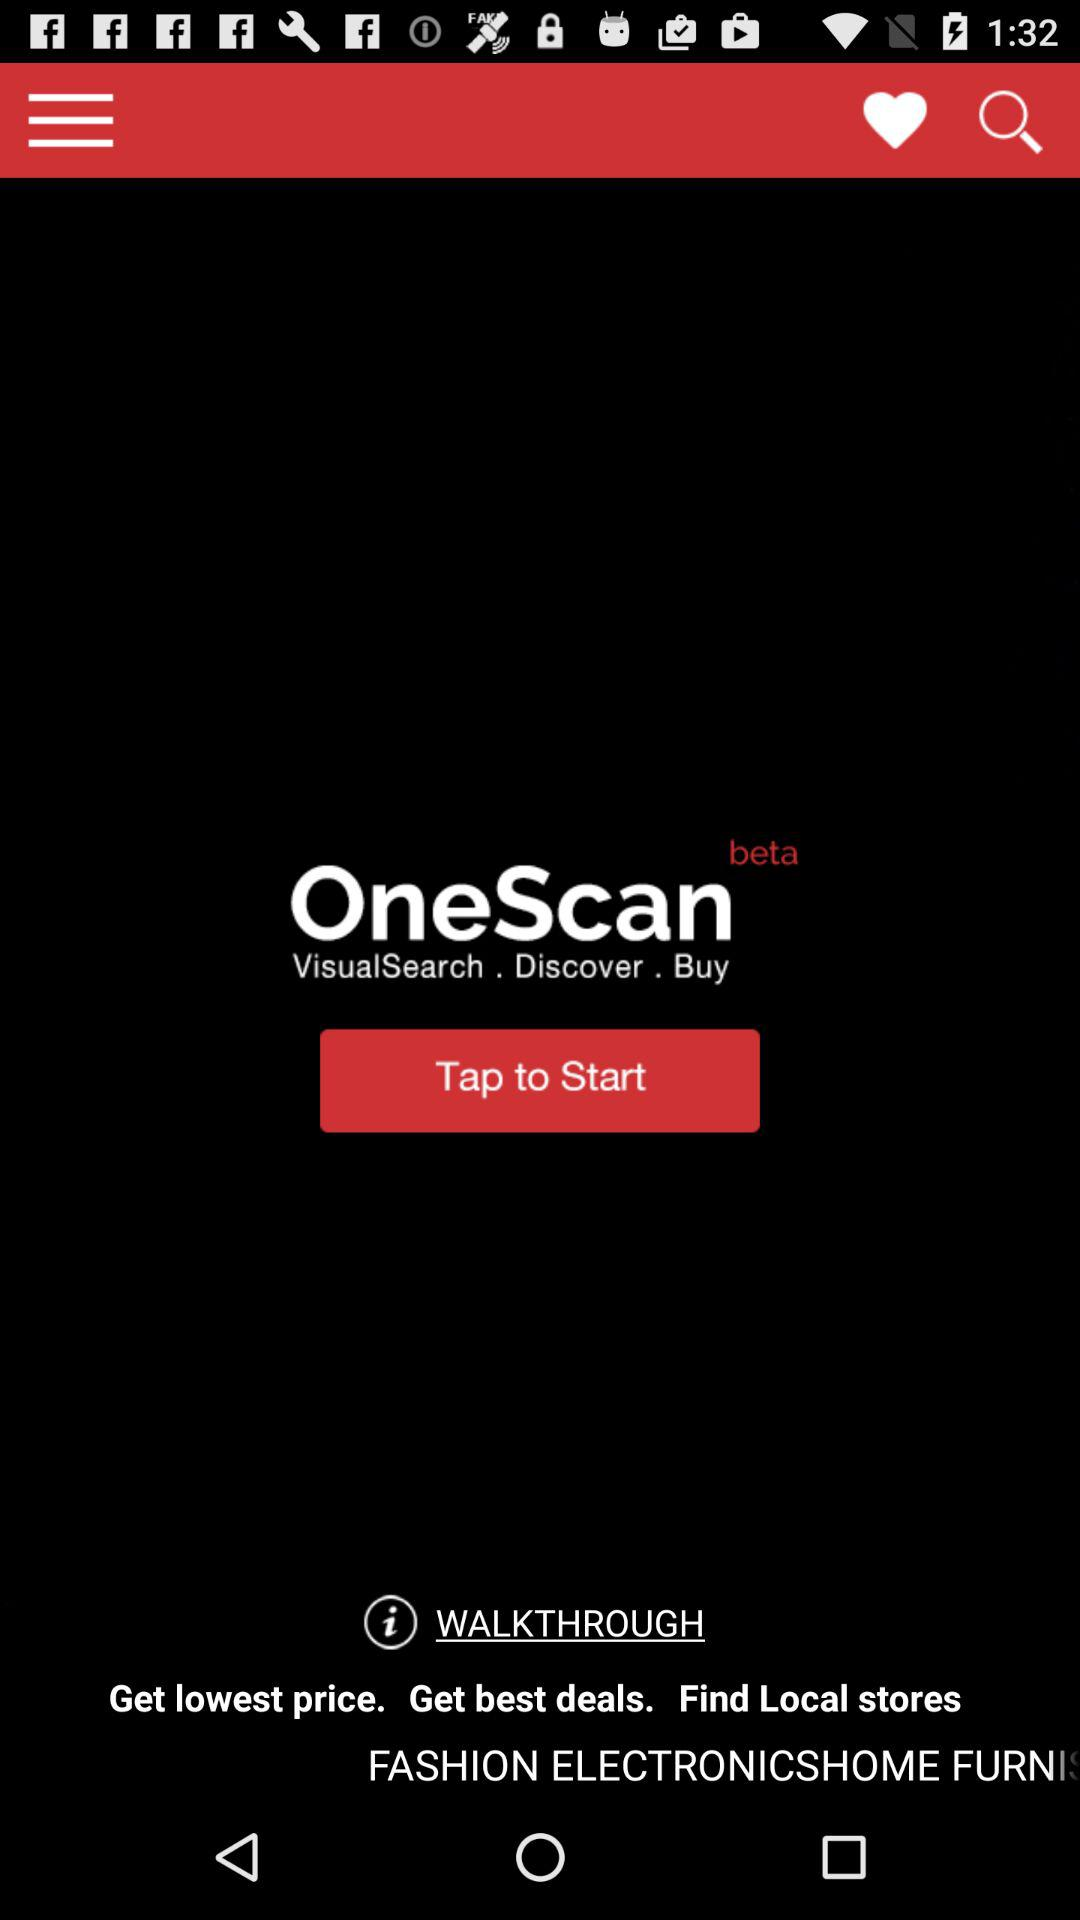What is the application name? The application name is "OneScan". 